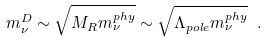Convert formula to latex. <formula><loc_0><loc_0><loc_500><loc_500>m ^ { D } _ { \nu } \sim \sqrt { M _ { R } m ^ { p h y } _ { \nu } } \sim \sqrt { \Lambda _ { p o l e } m ^ { p h y } _ { \nu } } \ .</formula> 